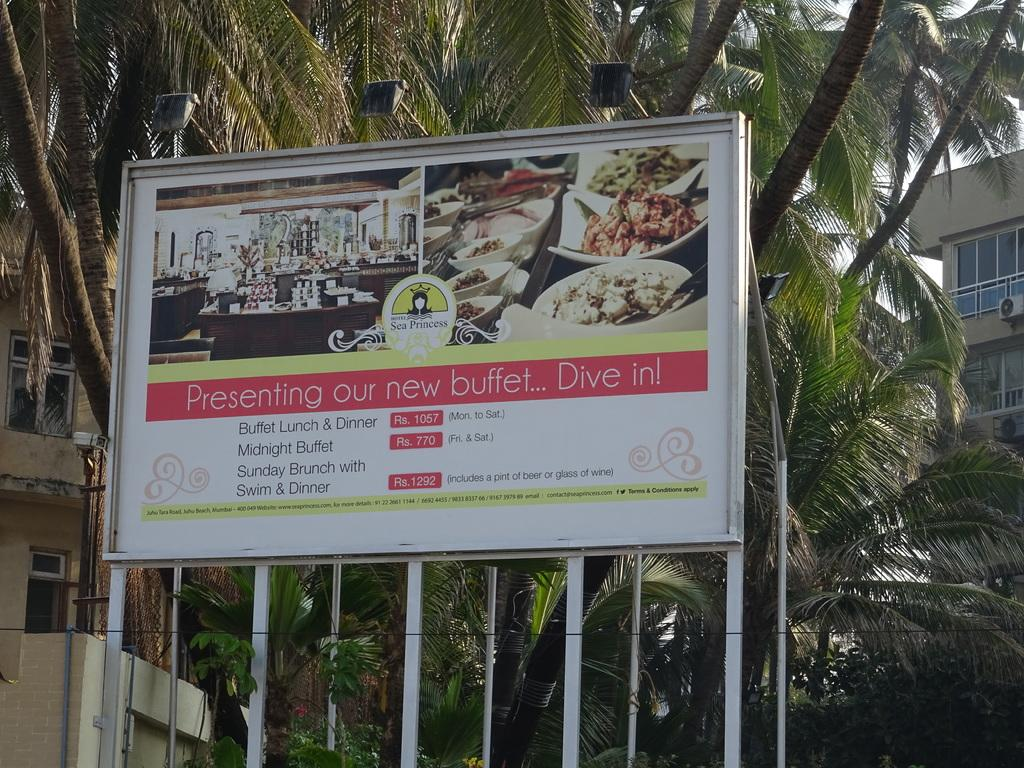What is the main subject in the center of the image? There is a hoarding in the center of the image. What can be seen in the background of the image? There are trees and buildings in the background of the image. Are there any other elements visible in the image? Yes, wires are visible in the image. Is there a volcano erupting in the background of the image? No, there is no volcano present in the image. Can you see a quilt being used as a decoration on the hoarding? No, there is no quilt visible in the image. 